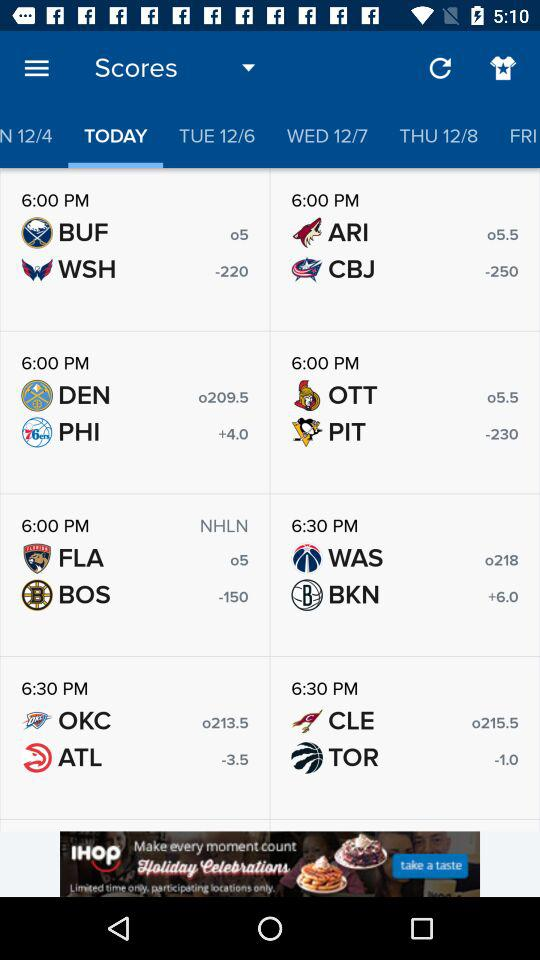What is the score of BUF and WSH? The scores of BUF and WSH are o5 and -220, respectively. 